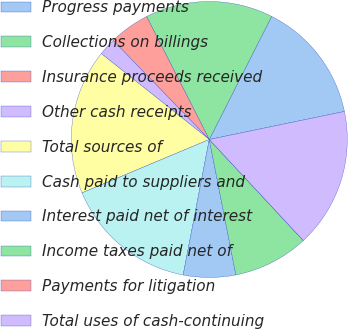Convert chart. <chart><loc_0><loc_0><loc_500><loc_500><pie_chart><fcel>Progress payments<fcel>Collections on billings<fcel>Insurance proceeds received<fcel>Other cash receipts<fcel>Total sources of<fcel>Cash paid to suppliers and<fcel>Interest paid net of interest<fcel>Income taxes paid net of<fcel>Payments for litigation<fcel>Total uses of cash-continuing<nl><fcel>14.28%<fcel>14.96%<fcel>4.76%<fcel>2.04%<fcel>17.01%<fcel>15.64%<fcel>6.12%<fcel>8.84%<fcel>0.0%<fcel>16.32%<nl></chart> 